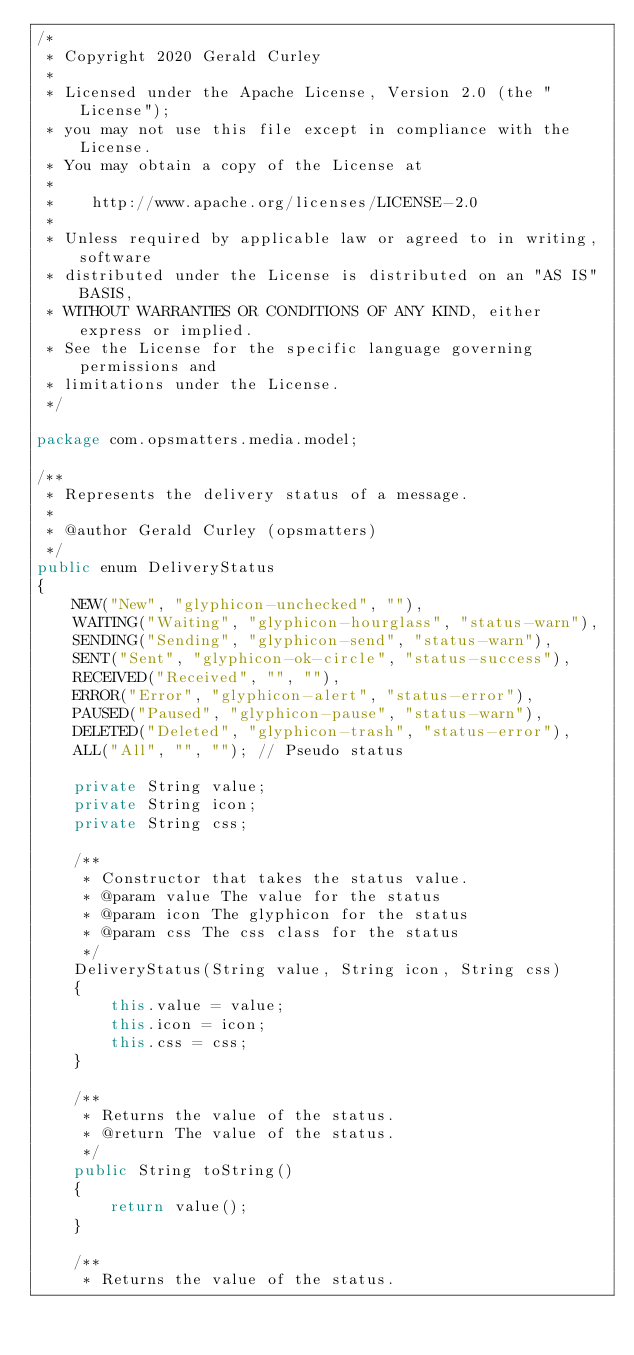Convert code to text. <code><loc_0><loc_0><loc_500><loc_500><_Java_>/*
 * Copyright 2020 Gerald Curley
 *
 * Licensed under the Apache License, Version 2.0 (the "License");
 * you may not use this file except in compliance with the License.
 * You may obtain a copy of the License at
 *
 *    http://www.apache.org/licenses/LICENSE-2.0
 *
 * Unless required by applicable law or agreed to in writing, software
 * distributed under the License is distributed on an "AS IS" BASIS,
 * WITHOUT WARRANTIES OR CONDITIONS OF ANY KIND, either express or implied.
 * See the License for the specific language governing permissions and
 * limitations under the License.
 */

package com.opsmatters.media.model;

/**
 * Represents the delivery status of a message.
 * 
 * @author Gerald Curley (opsmatters)
 */
public enum DeliveryStatus
{
    NEW("New", "glyphicon-unchecked", ""),
    WAITING("Waiting", "glyphicon-hourglass", "status-warn"),
    SENDING("Sending", "glyphicon-send", "status-warn"),
    SENT("Sent", "glyphicon-ok-circle", "status-success"),
    RECEIVED("Received", "", ""),
    ERROR("Error", "glyphicon-alert", "status-error"),
    PAUSED("Paused", "glyphicon-pause", "status-warn"),
    DELETED("Deleted", "glyphicon-trash", "status-error"),
    ALL("All", "", ""); // Pseudo status

    private String value;
    private String icon;
    private String css;

    /**
     * Constructor that takes the status value.
     * @param value The value for the status
     * @param icon The glyphicon for the status
     * @param css The css class for the status
     */
    DeliveryStatus(String value, String icon, String css)
    {
        this.value = value;
        this.icon = icon;
        this.css = css;
    }

    /**
     * Returns the value of the status.
     * @return The value of the status.
     */
    public String toString()
    {
        return value();
    }

    /**
     * Returns the value of the status.</code> 